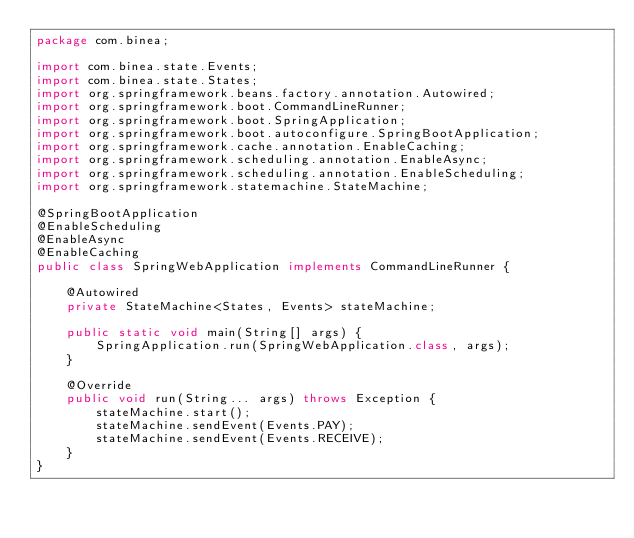Convert code to text. <code><loc_0><loc_0><loc_500><loc_500><_Java_>package com.binea;

import com.binea.state.Events;
import com.binea.state.States;
import org.springframework.beans.factory.annotation.Autowired;
import org.springframework.boot.CommandLineRunner;
import org.springframework.boot.SpringApplication;
import org.springframework.boot.autoconfigure.SpringBootApplication;
import org.springframework.cache.annotation.EnableCaching;
import org.springframework.scheduling.annotation.EnableAsync;
import org.springframework.scheduling.annotation.EnableScheduling;
import org.springframework.statemachine.StateMachine;

@SpringBootApplication
@EnableScheduling
@EnableAsync
@EnableCaching
public class SpringWebApplication implements CommandLineRunner {

    @Autowired
    private StateMachine<States, Events> stateMachine;

    public static void main(String[] args) {
        SpringApplication.run(SpringWebApplication.class, args);
    }

    @Override
    public void run(String... args) throws Exception {
        stateMachine.start();
        stateMachine.sendEvent(Events.PAY);
        stateMachine.sendEvent(Events.RECEIVE);
    }
}
</code> 